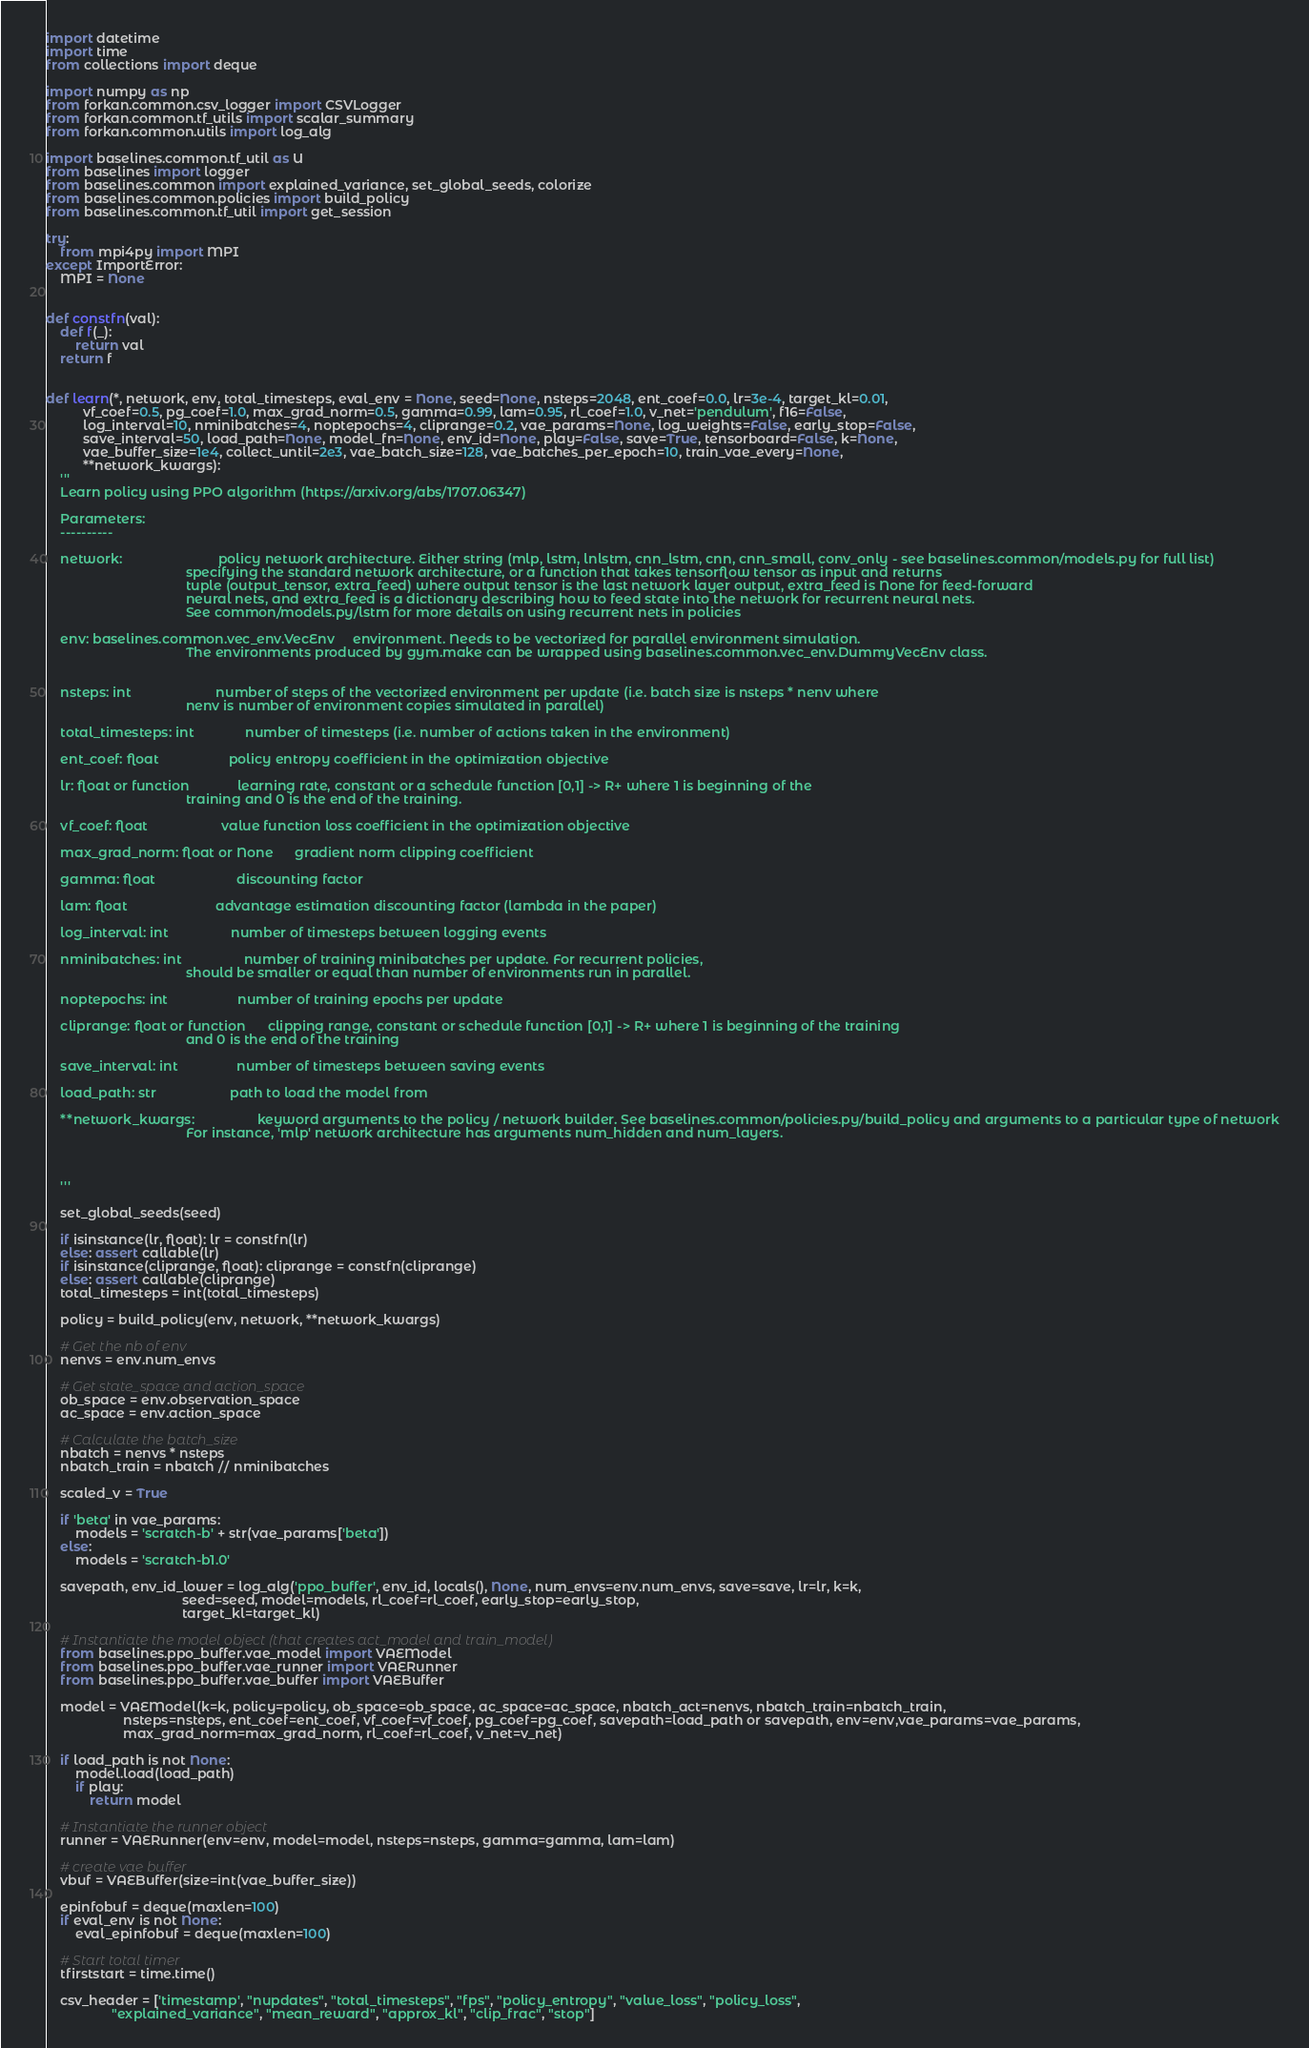<code> <loc_0><loc_0><loc_500><loc_500><_Python_>import datetime
import time
from collections import deque

import numpy as np
from forkan.common.csv_logger import CSVLogger
from forkan.common.tf_utils import scalar_summary
from forkan.common.utils import log_alg

import baselines.common.tf_util as U
from baselines import logger
from baselines.common import explained_variance, set_global_seeds, colorize
from baselines.common.policies import build_policy
from baselines.common.tf_util import get_session

try:
    from mpi4py import MPI
except ImportError:
    MPI = None


def constfn(val):
    def f(_):
        return val
    return f


def learn(*, network, env, total_timesteps, eval_env = None, seed=None, nsteps=2048, ent_coef=0.0, lr=3e-4, target_kl=0.01,
          vf_coef=0.5, pg_coef=1.0, max_grad_norm=0.5, gamma=0.99, lam=0.95, rl_coef=1.0, v_net='pendulum', f16=False,
          log_interval=10, nminibatches=4, noptepochs=4, cliprange=0.2, vae_params=None, log_weights=False, early_stop=False,
          save_interval=50, load_path=None, model_fn=None, env_id=None, play=False, save=True, tensorboard=False, k=None,
          vae_buffer_size=1e4, collect_until=2e3, vae_batch_size=128, vae_batches_per_epoch=10, train_vae_every=None,
          **network_kwargs):
    '''
    Learn policy using PPO algorithm (https://arxiv.org/abs/1707.06347)

    Parameters:
    ----------

    network:                          policy network architecture. Either string (mlp, lstm, lnlstm, cnn_lstm, cnn, cnn_small, conv_only - see baselines.common/models.py for full list)
                                      specifying the standard network architecture, or a function that takes tensorflow tensor as input and returns
                                      tuple (output_tensor, extra_feed) where output tensor is the last network layer output, extra_feed is None for feed-forward
                                      neural nets, and extra_feed is a dictionary describing how to feed state into the network for recurrent neural nets.
                                      See common/models.py/lstm for more details on using recurrent nets in policies

    env: baselines.common.vec_env.VecEnv     environment. Needs to be vectorized for parallel environment simulation.
                                      The environments produced by gym.make can be wrapped using baselines.common.vec_env.DummyVecEnv class.


    nsteps: int                       number of steps of the vectorized environment per update (i.e. batch size is nsteps * nenv where
                                      nenv is number of environment copies simulated in parallel)

    total_timesteps: int              number of timesteps (i.e. number of actions taken in the environment)

    ent_coef: float                   policy entropy coefficient in the optimization objective

    lr: float or function             learning rate, constant or a schedule function [0,1] -> R+ where 1 is beginning of the
                                      training and 0 is the end of the training.

    vf_coef: float                    value function loss coefficient in the optimization objective

    max_grad_norm: float or None      gradient norm clipping coefficient

    gamma: float                      discounting factor

    lam: float                        advantage estimation discounting factor (lambda in the paper)

    log_interval: int                 number of timesteps between logging events

    nminibatches: int                 number of training minibatches per update. For recurrent policies,
                                      should be smaller or equal than number of environments run in parallel.

    noptepochs: int                   number of training epochs per update

    cliprange: float or function      clipping range, constant or schedule function [0,1] -> R+ where 1 is beginning of the training
                                      and 0 is the end of the training

    save_interval: int                number of timesteps between saving events

    load_path: str                    path to load the model from

    **network_kwargs:                 keyword arguments to the policy / network builder. See baselines.common/policies.py/build_policy and arguments to a particular type of network
                                      For instance, 'mlp' network architecture has arguments num_hidden and num_layers.



    '''

    set_global_seeds(seed)

    if isinstance(lr, float): lr = constfn(lr)
    else: assert callable(lr)
    if isinstance(cliprange, float): cliprange = constfn(cliprange)
    else: assert callable(cliprange)
    total_timesteps = int(total_timesteps)

    policy = build_policy(env, network, **network_kwargs)

    # Get the nb of env
    nenvs = env.num_envs

    # Get state_space and action_space
    ob_space = env.observation_space
    ac_space = env.action_space

    # Calculate the batch_size
    nbatch = nenvs * nsteps
    nbatch_train = nbatch // nminibatches

    scaled_v = True

    if 'beta' in vae_params:
        models = 'scratch-b' + str(vae_params['beta'])
    else:
        models = 'scratch-b1.0'

    savepath, env_id_lower = log_alg('ppo_buffer', env_id, locals(), None, num_envs=env.num_envs, save=save, lr=lr, k=k,
                                     seed=seed, model=models, rl_coef=rl_coef, early_stop=early_stop,
                                     target_kl=target_kl)

    # Instantiate the model object (that creates act_model and train_model)
    from baselines.ppo_buffer.vae_model import VAEModel
    from baselines.ppo_buffer.vae_runner import VAERunner
    from baselines.ppo_buffer.vae_buffer import VAEBuffer

    model = VAEModel(k=k, policy=policy, ob_space=ob_space, ac_space=ac_space, nbatch_act=nenvs, nbatch_train=nbatch_train,
                     nsteps=nsteps, ent_coef=ent_coef, vf_coef=vf_coef, pg_coef=pg_coef, savepath=load_path or savepath, env=env,vae_params=vae_params,
                     max_grad_norm=max_grad_norm, rl_coef=rl_coef, v_net=v_net)

    if load_path is not None:
        model.load(load_path)
        if play:
            return model

    # Instantiate the runner object
    runner = VAERunner(env=env, model=model, nsteps=nsteps, gamma=gamma, lam=lam)

    # create vae buffer
    vbuf = VAEBuffer(size=int(vae_buffer_size))

    epinfobuf = deque(maxlen=100)
    if eval_env is not None:
        eval_epinfobuf = deque(maxlen=100)

    # Start total timer
    tfirststart = time.time()

    csv_header = ['timestamp', "nupdates", "total_timesteps", "fps", "policy_entropy", "value_loss", "policy_loss",
                  "explained_variance", "mean_reward", "approx_kl", "clip_frac", "stop"]</code> 